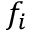Convert formula to latex. <formula><loc_0><loc_0><loc_500><loc_500>f _ { i }</formula> 